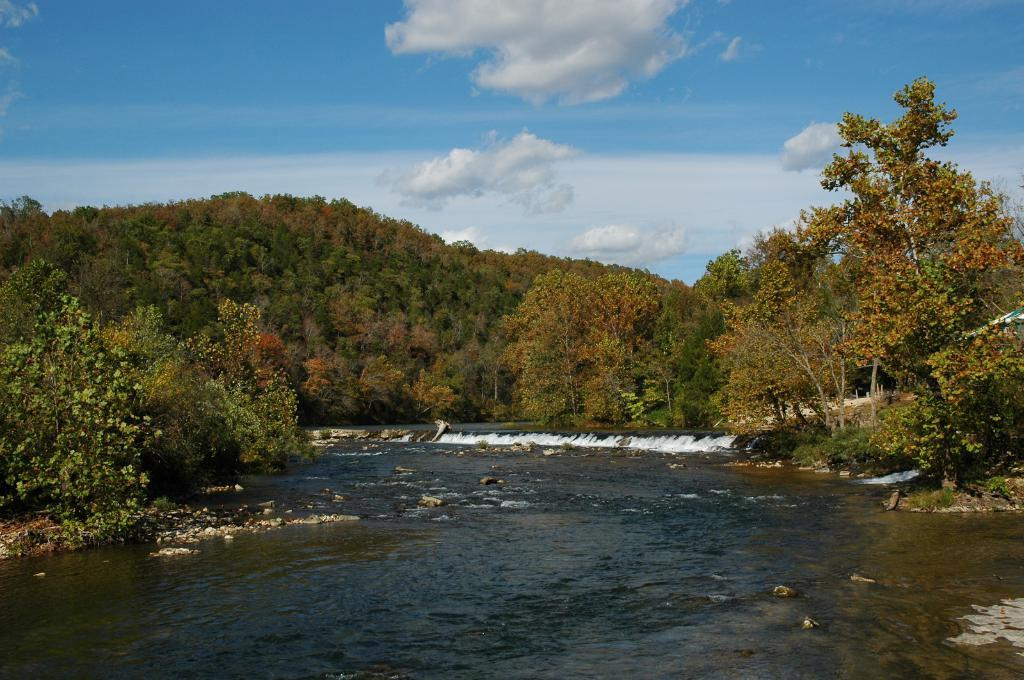What is present in the front of the image? There is water in the front of the image. What can be seen in the background of the image? There are trees in the background of the image. How would you describe the sky in the image? The sky is cloudy in the image. How does the war affect the use of the comb in the image? There is no war or comb present in the image. What type of comb is being used in the image? There is no comb present in the image. 